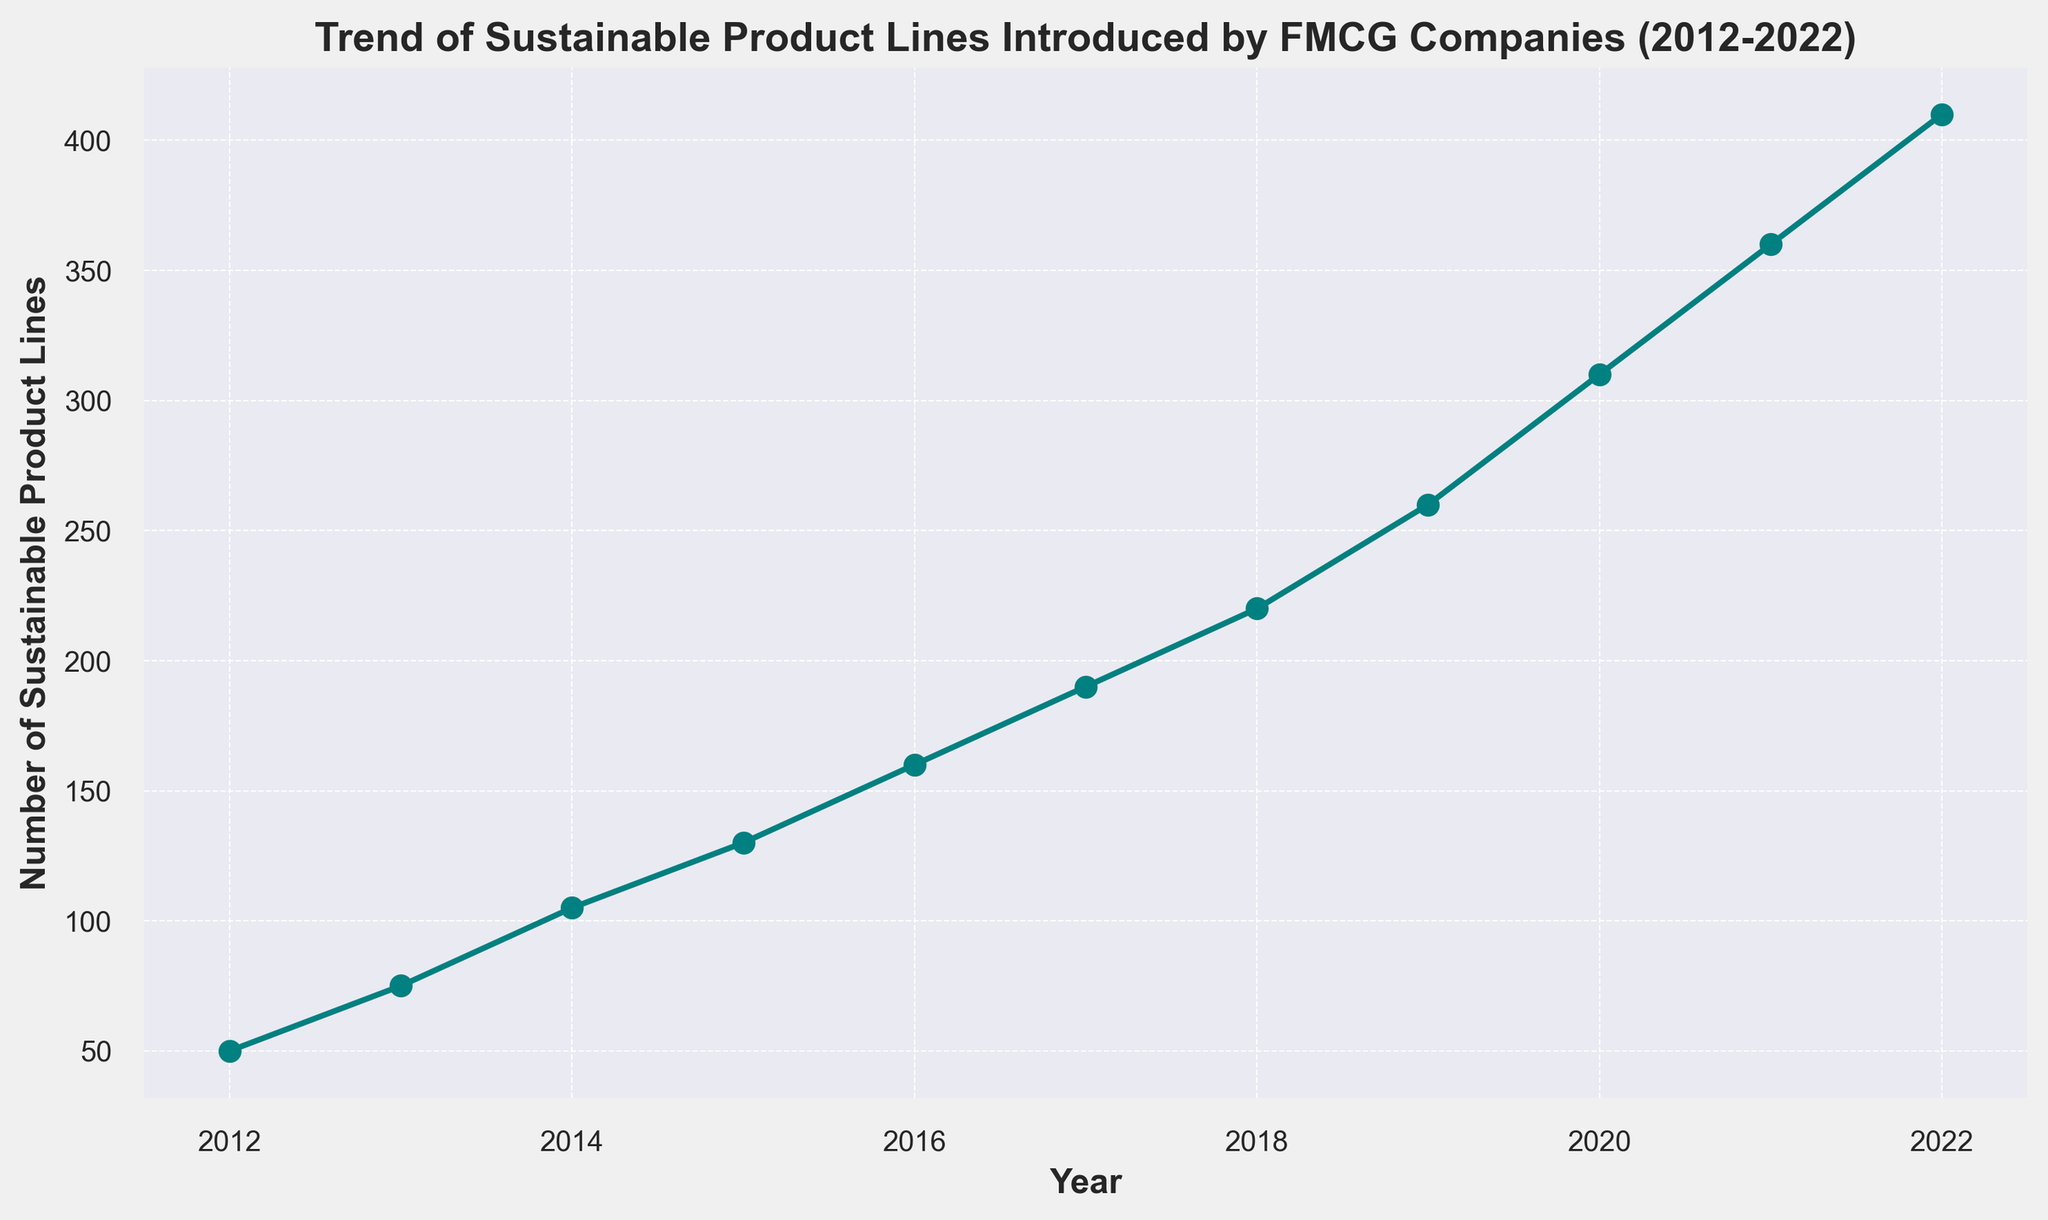What is the total number of sustainable product lines introduced from 2016 to 2022? To find the total number of sustainable product lines introduced from 2016 to 2022, sum the values for those years: 160 (2016) + 190 (2017) + 220 (2018) + 260 (2019) + 310 (2020) + 360 (2021) + 410 (2022) = 1910
Answer: 1910 By how much did the number of sustainable product lines increase from 2012 to 2022? To find the increase, subtract the number of sustainable product lines in 2012 from that in 2022: 410 (2022) - 50 (2012) = 360
Answer: 360 What is the average annual increase in the number of sustainable product lines from 2012 to 2022? First, find the total increase over the 10 years (360), then divide by the number of years (2022-2012 = 10): 360 / 10 = 36
Answer: 36 Which year saw the highest increase in the number of sustainable product lines compared to the previous year? Calculate the year-over-year increases and find the maximum: 
2013-2012 = 25
2014-2013 = 30
2015-2014 = 25
2016-2015 = 30
2017-2016 = 30
2018-2017 = 30
2019-2018 = 40
2020-2019 = 50
2021-2020 = 50
2022-2021 = 50 
The highest increase of 50 occurred in 2020, 2021, and 2022.
Answer: 2020, 2021, and 2022 What proportion of the total number of sustainable product lines were introduced by 2017? First, sum the number of sustainable product lines introduced by 2017: 50 (2012) + 75 (2013) + 105 (2014) + 130 (2015) + 160 (2016) + 190 (2017) = 710. Then, sum the total number from 2012 to 2022: 310 + 360 + 410 + 710 + 75 + 105 + 130 + 160 + 190 + 220 + 260 = 2490. Finally, find the proportion: 710 / 2490 ≈ 0.285
Answer: Approximately 0.285 